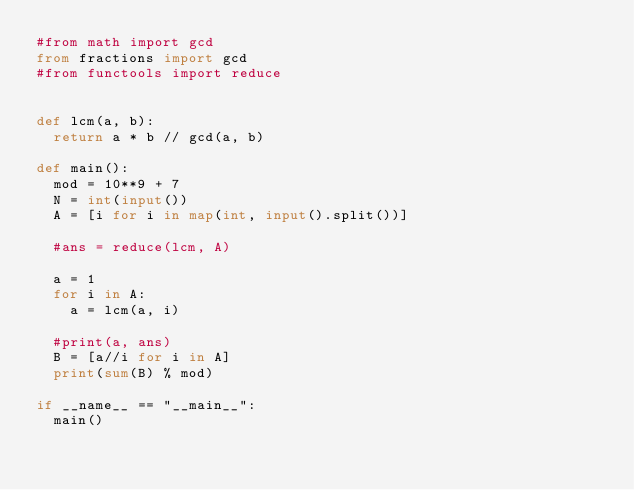<code> <loc_0><loc_0><loc_500><loc_500><_Python_>#from math import gcd
from fractions import gcd
#from functools import reduce


def lcm(a, b):
	return a * b // gcd(a, b)

def main():
	mod = 10**9 + 7
	N = int(input())
	A = [i for i in map(int, input().split())]
	
	#ans = reduce(lcm, A)
	
	a = 1
	for i in A:
		a = lcm(a, i)

	#print(a, ans)
	B = [a//i for i in A]
	print(sum(B) % mod)

if __name__ == "__main__":
	main()
</code> 